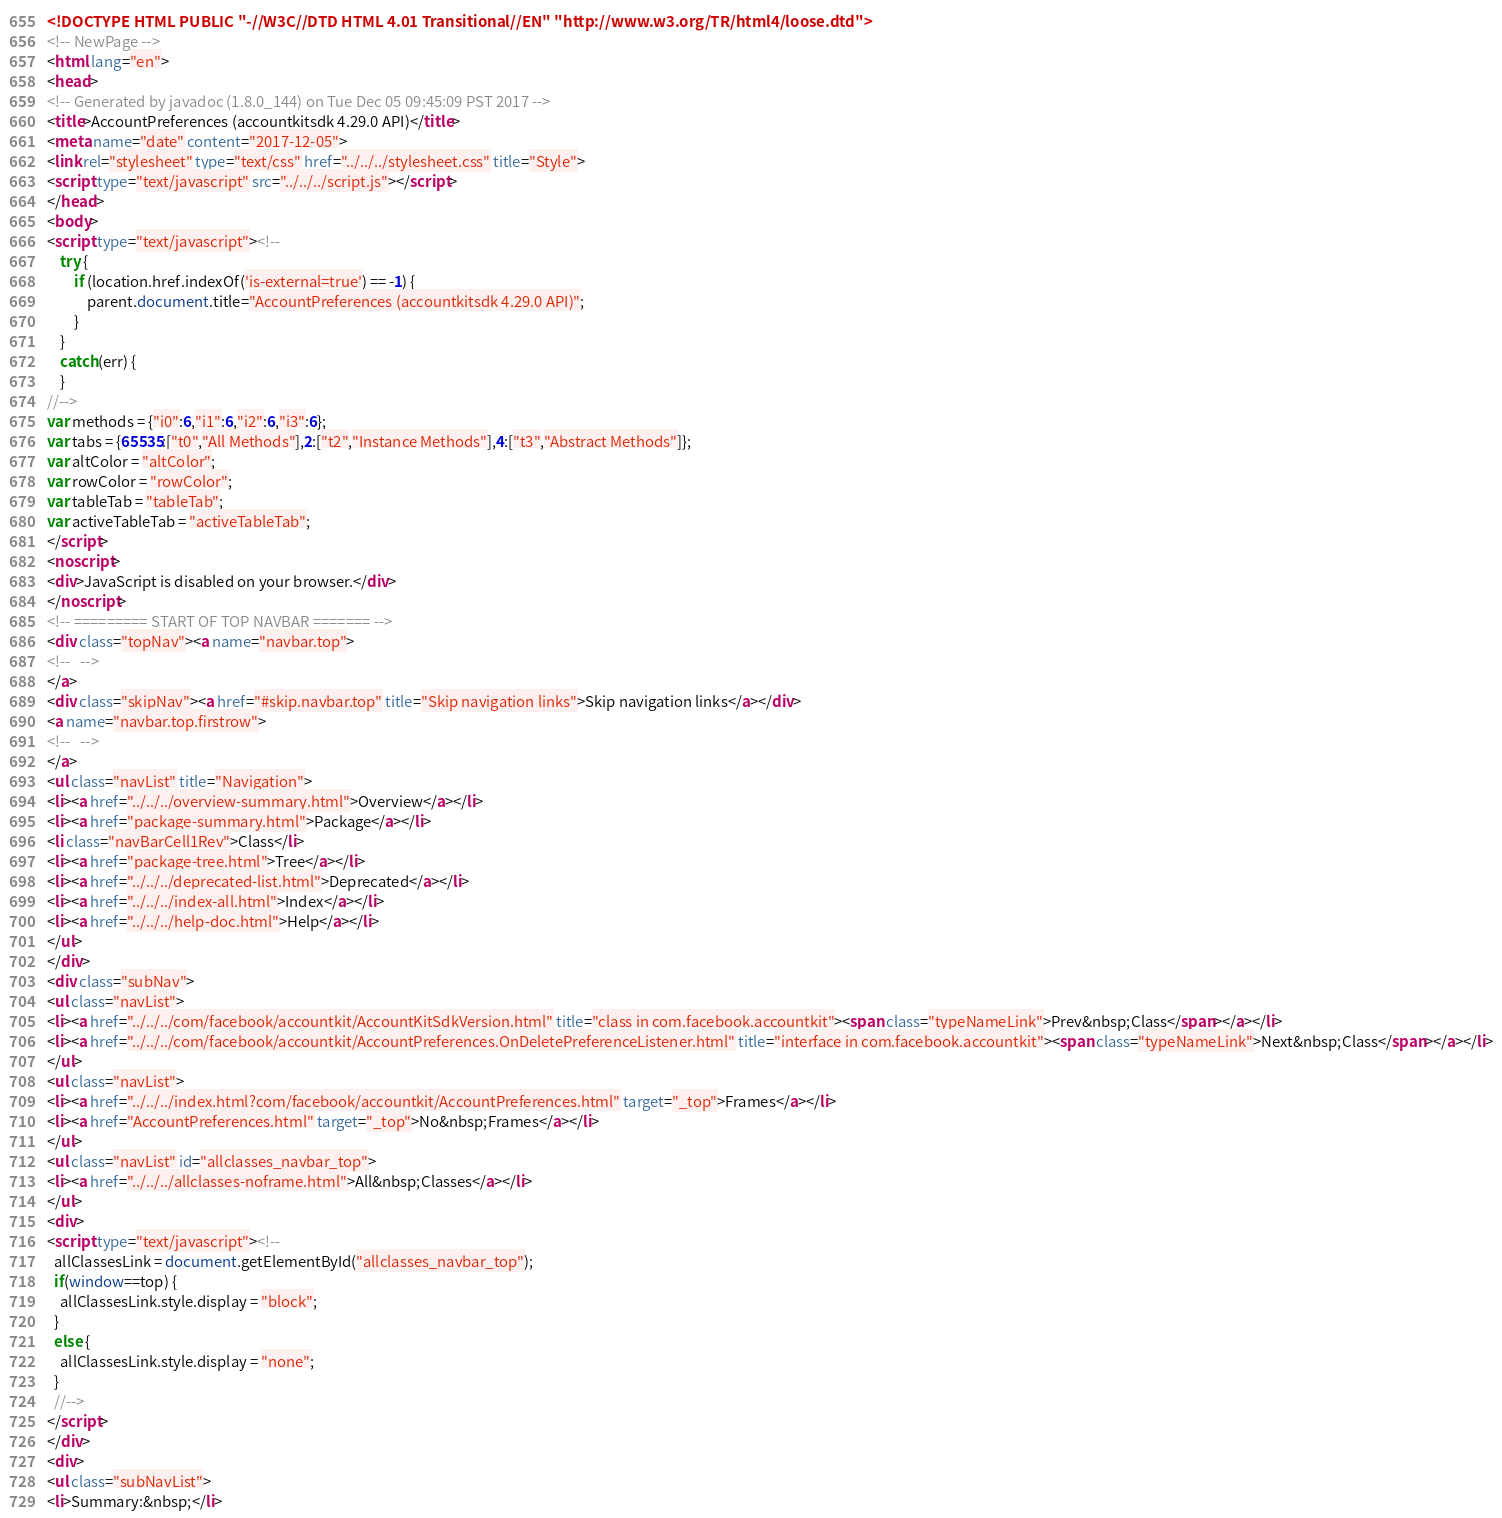Convert code to text. <code><loc_0><loc_0><loc_500><loc_500><_HTML_><!DOCTYPE HTML PUBLIC "-//W3C//DTD HTML 4.01 Transitional//EN" "http://www.w3.org/TR/html4/loose.dtd">
<!-- NewPage -->
<html lang="en">
<head>
<!-- Generated by javadoc (1.8.0_144) on Tue Dec 05 09:45:09 PST 2017 -->
<title>AccountPreferences (accountkitsdk 4.29.0 API)</title>
<meta name="date" content="2017-12-05">
<link rel="stylesheet" type="text/css" href="../../../stylesheet.css" title="Style">
<script type="text/javascript" src="../../../script.js"></script>
</head>
<body>
<script type="text/javascript"><!--
    try {
        if (location.href.indexOf('is-external=true') == -1) {
            parent.document.title="AccountPreferences (accountkitsdk 4.29.0 API)";
        }
    }
    catch(err) {
    }
//-->
var methods = {"i0":6,"i1":6,"i2":6,"i3":6};
var tabs = {65535:["t0","All Methods"],2:["t2","Instance Methods"],4:["t3","Abstract Methods"]};
var altColor = "altColor";
var rowColor = "rowColor";
var tableTab = "tableTab";
var activeTableTab = "activeTableTab";
</script>
<noscript>
<div>JavaScript is disabled on your browser.</div>
</noscript>
<!-- ========= START OF TOP NAVBAR ======= -->
<div class="topNav"><a name="navbar.top">
<!--   -->
</a>
<div class="skipNav"><a href="#skip.navbar.top" title="Skip navigation links">Skip navigation links</a></div>
<a name="navbar.top.firstrow">
<!--   -->
</a>
<ul class="navList" title="Navigation">
<li><a href="../../../overview-summary.html">Overview</a></li>
<li><a href="package-summary.html">Package</a></li>
<li class="navBarCell1Rev">Class</li>
<li><a href="package-tree.html">Tree</a></li>
<li><a href="../../../deprecated-list.html">Deprecated</a></li>
<li><a href="../../../index-all.html">Index</a></li>
<li><a href="../../../help-doc.html">Help</a></li>
</ul>
</div>
<div class="subNav">
<ul class="navList">
<li><a href="../../../com/facebook/accountkit/AccountKitSdkVersion.html" title="class in com.facebook.accountkit"><span class="typeNameLink">Prev&nbsp;Class</span></a></li>
<li><a href="../../../com/facebook/accountkit/AccountPreferences.OnDeletePreferenceListener.html" title="interface in com.facebook.accountkit"><span class="typeNameLink">Next&nbsp;Class</span></a></li>
</ul>
<ul class="navList">
<li><a href="../../../index.html?com/facebook/accountkit/AccountPreferences.html" target="_top">Frames</a></li>
<li><a href="AccountPreferences.html" target="_top">No&nbsp;Frames</a></li>
</ul>
<ul class="navList" id="allclasses_navbar_top">
<li><a href="../../../allclasses-noframe.html">All&nbsp;Classes</a></li>
</ul>
<div>
<script type="text/javascript"><!--
  allClassesLink = document.getElementById("allclasses_navbar_top");
  if(window==top) {
    allClassesLink.style.display = "block";
  }
  else {
    allClassesLink.style.display = "none";
  }
  //-->
</script>
</div>
<div>
<ul class="subNavList">
<li>Summary:&nbsp;</li></code> 